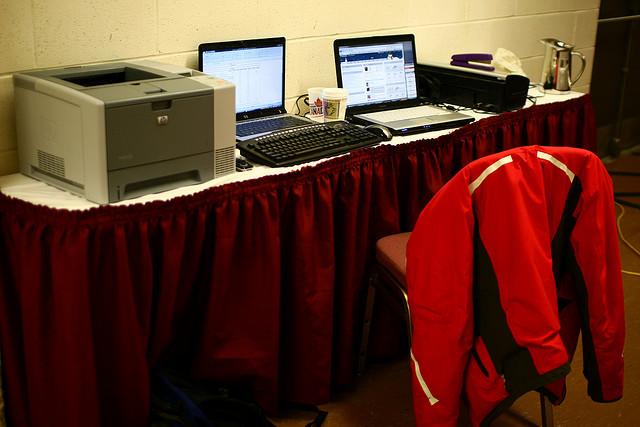What color is contrasting the red on the jacket?
Answer briefly. White. How many keyboards are on the table?
Be succinct. 2. Is the pitcher's handle facing the wall?
Answer briefly. No. 